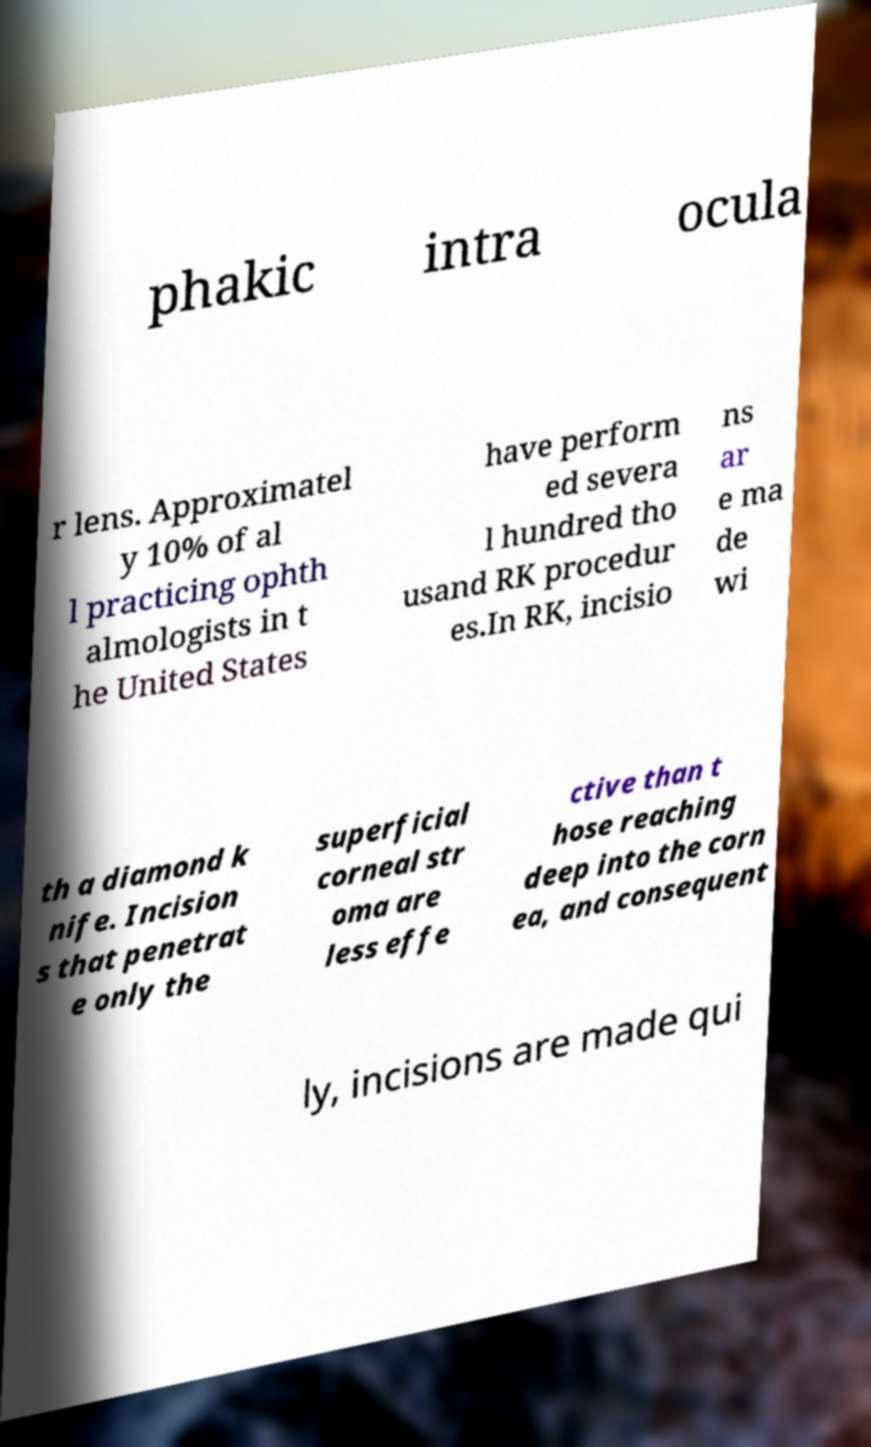I need the written content from this picture converted into text. Can you do that? phakic intra ocula r lens. Approximatel y 10% of al l practicing ophth almologists in t he United States have perform ed severa l hundred tho usand RK procedur es.In RK, incisio ns ar e ma de wi th a diamond k nife. Incision s that penetrat e only the superficial corneal str oma are less effe ctive than t hose reaching deep into the corn ea, and consequent ly, incisions are made qui 